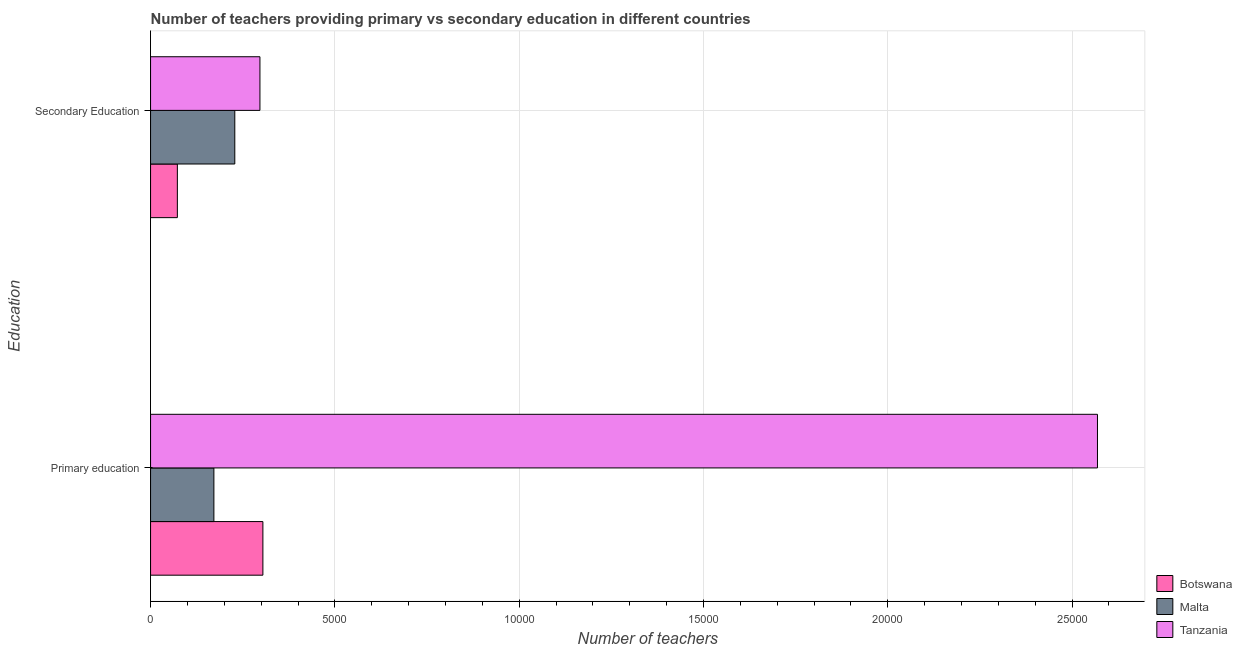How many different coloured bars are there?
Give a very brief answer. 3. What is the label of the 1st group of bars from the top?
Provide a short and direct response. Secondary Education. What is the number of secondary teachers in Tanzania?
Offer a very short reply. 2967. Across all countries, what is the maximum number of primary teachers?
Keep it short and to the point. 2.57e+04. Across all countries, what is the minimum number of secondary teachers?
Your response must be concise. 727. In which country was the number of primary teachers maximum?
Make the answer very short. Tanzania. In which country was the number of secondary teachers minimum?
Keep it short and to the point. Botswana. What is the total number of secondary teachers in the graph?
Provide a short and direct response. 5979. What is the difference between the number of primary teachers in Botswana and that in Tanzania?
Offer a very short reply. -2.26e+04. What is the difference between the number of primary teachers in Tanzania and the number of secondary teachers in Malta?
Offer a terse response. 2.34e+04. What is the average number of secondary teachers per country?
Offer a terse response. 1993. What is the difference between the number of secondary teachers and number of primary teachers in Tanzania?
Your answer should be very brief. -2.27e+04. In how many countries, is the number of secondary teachers greater than 6000 ?
Offer a very short reply. 0. What is the ratio of the number of secondary teachers in Malta to that in Tanzania?
Give a very brief answer. 0.77. In how many countries, is the number of secondary teachers greater than the average number of secondary teachers taken over all countries?
Your answer should be very brief. 2. What does the 1st bar from the top in Secondary Education represents?
Provide a succinct answer. Tanzania. What does the 1st bar from the bottom in Primary education represents?
Give a very brief answer. Botswana. How many bars are there?
Give a very brief answer. 6. Are all the bars in the graph horizontal?
Give a very brief answer. Yes. How many countries are there in the graph?
Your answer should be compact. 3. What is the difference between two consecutive major ticks on the X-axis?
Provide a short and direct response. 5000. Are the values on the major ticks of X-axis written in scientific E-notation?
Give a very brief answer. No. Does the graph contain grids?
Make the answer very short. Yes. Where does the legend appear in the graph?
Your answer should be very brief. Bottom right. How many legend labels are there?
Provide a short and direct response. 3. How are the legend labels stacked?
Provide a succinct answer. Vertical. What is the title of the graph?
Ensure brevity in your answer.  Number of teachers providing primary vs secondary education in different countries. Does "Grenada" appear as one of the legend labels in the graph?
Provide a succinct answer. No. What is the label or title of the X-axis?
Keep it short and to the point. Number of teachers. What is the label or title of the Y-axis?
Your answer should be very brief. Education. What is the Number of teachers of Botswana in Primary education?
Give a very brief answer. 3047. What is the Number of teachers of Malta in Primary education?
Keep it short and to the point. 1718. What is the Number of teachers in Tanzania in Primary education?
Provide a short and direct response. 2.57e+04. What is the Number of teachers of Botswana in Secondary Education?
Provide a succinct answer. 727. What is the Number of teachers in Malta in Secondary Education?
Ensure brevity in your answer.  2285. What is the Number of teachers of Tanzania in Secondary Education?
Your answer should be very brief. 2967. Across all Education, what is the maximum Number of teachers of Botswana?
Your answer should be compact. 3047. Across all Education, what is the maximum Number of teachers of Malta?
Make the answer very short. 2285. Across all Education, what is the maximum Number of teachers of Tanzania?
Your answer should be very brief. 2.57e+04. Across all Education, what is the minimum Number of teachers in Botswana?
Ensure brevity in your answer.  727. Across all Education, what is the minimum Number of teachers in Malta?
Ensure brevity in your answer.  1718. Across all Education, what is the minimum Number of teachers in Tanzania?
Offer a very short reply. 2967. What is the total Number of teachers in Botswana in the graph?
Your answer should be very brief. 3774. What is the total Number of teachers of Malta in the graph?
Offer a very short reply. 4003. What is the total Number of teachers in Tanzania in the graph?
Give a very brief answer. 2.87e+04. What is the difference between the Number of teachers of Botswana in Primary education and that in Secondary Education?
Make the answer very short. 2320. What is the difference between the Number of teachers of Malta in Primary education and that in Secondary Education?
Give a very brief answer. -567. What is the difference between the Number of teachers of Tanzania in Primary education and that in Secondary Education?
Your answer should be compact. 2.27e+04. What is the difference between the Number of teachers in Botswana in Primary education and the Number of teachers in Malta in Secondary Education?
Make the answer very short. 762. What is the difference between the Number of teachers of Botswana in Primary education and the Number of teachers of Tanzania in Secondary Education?
Ensure brevity in your answer.  80. What is the difference between the Number of teachers in Malta in Primary education and the Number of teachers in Tanzania in Secondary Education?
Your response must be concise. -1249. What is the average Number of teachers of Botswana per Education?
Make the answer very short. 1887. What is the average Number of teachers of Malta per Education?
Give a very brief answer. 2001.5. What is the average Number of teachers of Tanzania per Education?
Make the answer very short. 1.43e+04. What is the difference between the Number of teachers in Botswana and Number of teachers in Malta in Primary education?
Give a very brief answer. 1329. What is the difference between the Number of teachers in Botswana and Number of teachers in Tanzania in Primary education?
Offer a very short reply. -2.26e+04. What is the difference between the Number of teachers in Malta and Number of teachers in Tanzania in Primary education?
Your answer should be compact. -2.40e+04. What is the difference between the Number of teachers in Botswana and Number of teachers in Malta in Secondary Education?
Ensure brevity in your answer.  -1558. What is the difference between the Number of teachers of Botswana and Number of teachers of Tanzania in Secondary Education?
Offer a very short reply. -2240. What is the difference between the Number of teachers of Malta and Number of teachers of Tanzania in Secondary Education?
Your answer should be very brief. -682. What is the ratio of the Number of teachers in Botswana in Primary education to that in Secondary Education?
Keep it short and to the point. 4.19. What is the ratio of the Number of teachers of Malta in Primary education to that in Secondary Education?
Offer a very short reply. 0.75. What is the ratio of the Number of teachers of Tanzania in Primary education to that in Secondary Education?
Make the answer very short. 8.66. What is the difference between the highest and the second highest Number of teachers of Botswana?
Your response must be concise. 2320. What is the difference between the highest and the second highest Number of teachers in Malta?
Your answer should be very brief. 567. What is the difference between the highest and the second highest Number of teachers of Tanzania?
Make the answer very short. 2.27e+04. What is the difference between the highest and the lowest Number of teachers in Botswana?
Your response must be concise. 2320. What is the difference between the highest and the lowest Number of teachers of Malta?
Keep it short and to the point. 567. What is the difference between the highest and the lowest Number of teachers of Tanzania?
Ensure brevity in your answer.  2.27e+04. 